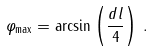Convert formula to latex. <formula><loc_0><loc_0><loc_500><loc_500>\varphi _ { \max } = \arcsin \left ( \frac { d l } { 4 } \right ) \, .</formula> 